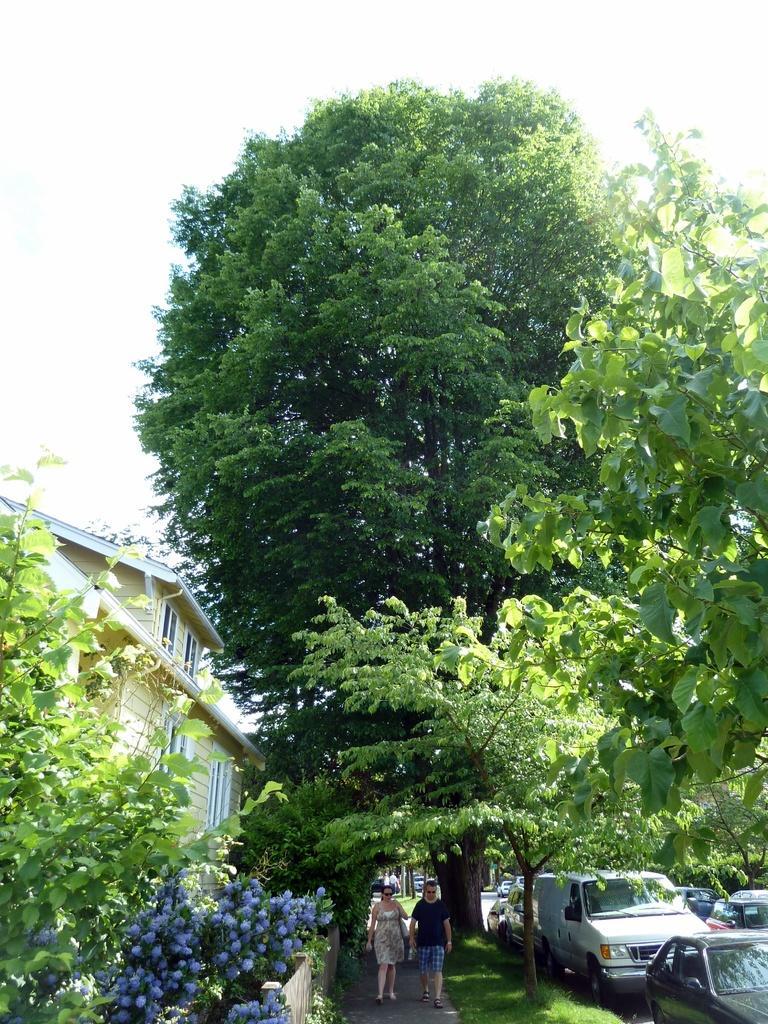Describe this image in one or two sentences. This picture is clicked outside. In the center we can see the two persons walking on the ground. On the left we can see the plants, flowers. On the right we can see the green grass and group of vehicles and we can see the trees and the house and we can see the windows of the house. In the background we can see the sky and some other objects. 